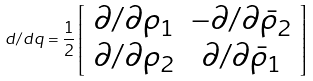Convert formula to latex. <formula><loc_0><loc_0><loc_500><loc_500>d / d q = \frac { 1 } { 2 } \left [ { \begin{array} { c c } { \partial / \partial { \rho _ { 1 } } } & { - \partial / \partial { \bar { \rho } _ { 2 } } } \\ { \partial / \partial { \rho _ { 2 } } } & { \partial / \partial { \bar { \rho } _ { 1 } } } \end{array} } \right ]</formula> 